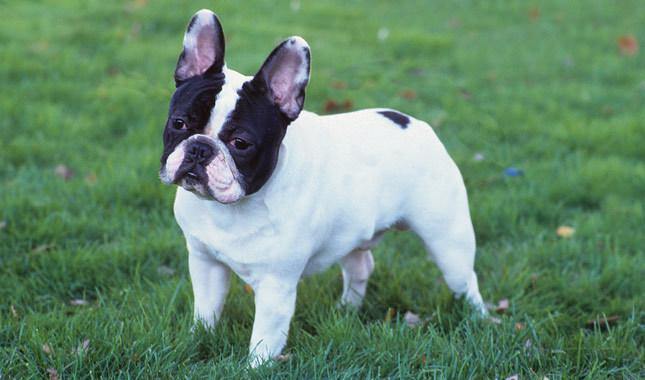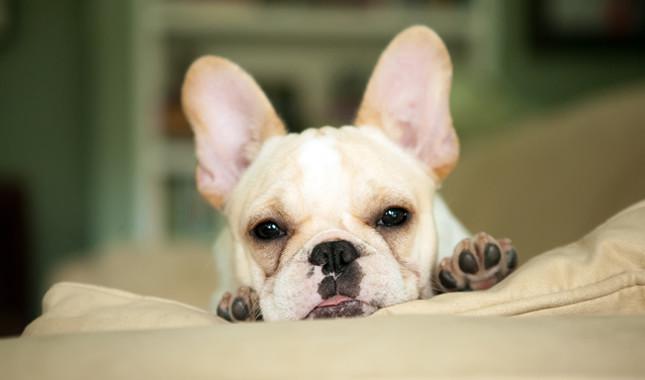The first image is the image on the left, the second image is the image on the right. Evaluate the accuracy of this statement regarding the images: "The dog is resting on a bed or couch and is photographed alone.". Is it true? Answer yes or no. Yes. 